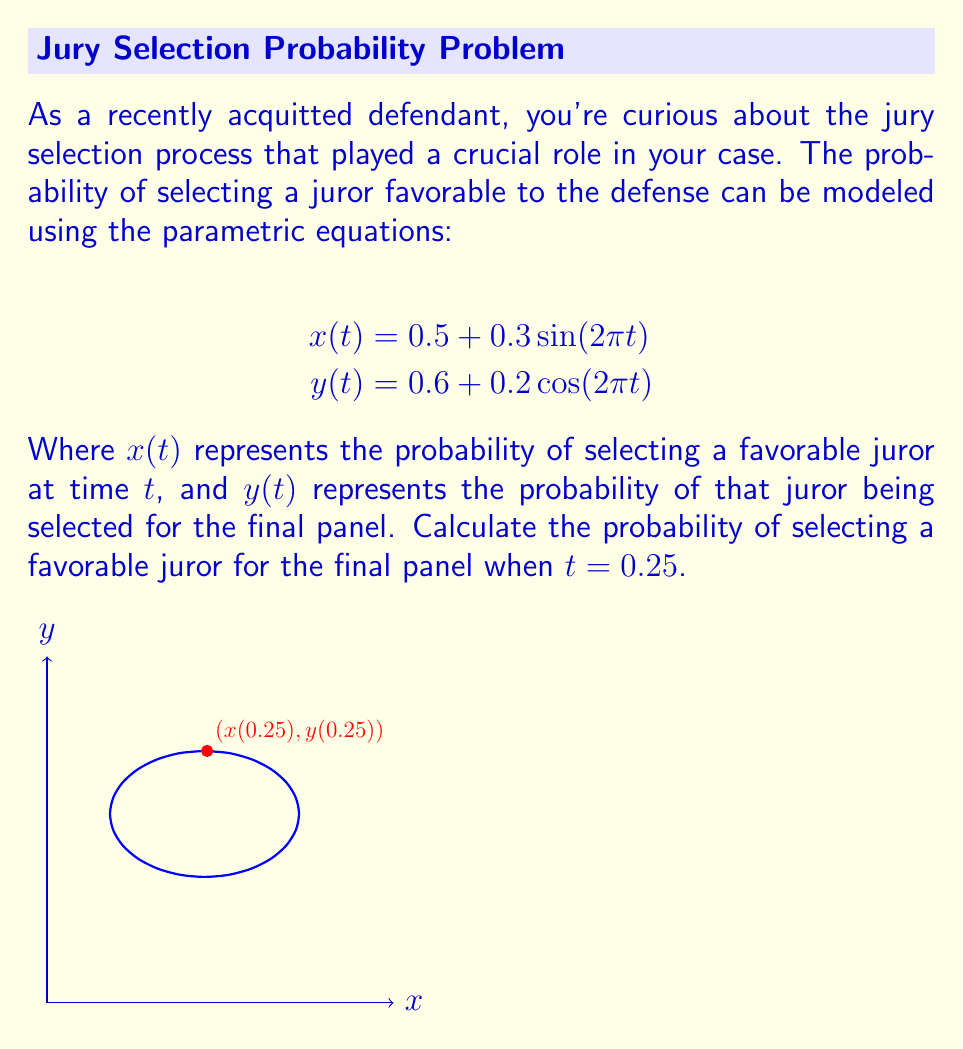Can you solve this math problem? To solve this problem, we'll follow these steps:

1) First, we need to calculate $x(0.25)$ and $y(0.25)$.

2) For $x(0.25)$:
   $$x(0.25) = 0.5 + 0.3\sin(2\pi(0.25))$$
   $$= 0.5 + 0.3\sin(\frac{\pi}{2})$$
   $$= 0.5 + 0.3(1)$$
   $$= 0.8$$

3) For $y(0.25)$:
   $$y(0.25) = 0.6 + 0.2\cos(2\pi(0.25))$$
   $$= 0.6 + 0.2\cos(\frac{\pi}{2})$$
   $$= 0.6 + 0.2(0)$$
   $$= 0.6$$

4) The probability of selecting a favorable juror at $t=0.25$ is $x(0.25) = 0.8$.

5) The probability of that juror being selected for the final panel is $y(0.25) = 0.6$.

6) To find the probability of both events occurring (selecting a favorable juror AND that juror being selected for the final panel), we multiply these probabilities:

   $$P(\text{favorable juror in final panel}) = x(0.25) \cdot y(0.25) = 0.8 \cdot 0.6 = 0.48$$

Therefore, the probability of selecting a favorable juror for the final panel when $t = 0.25$ is 0.48 or 48%.
Answer: 0.48 